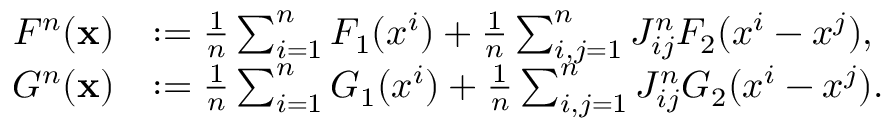Convert formula to latex. <formula><loc_0><loc_0><loc_500><loc_500>\begin{array} { r l } { F ^ { n } ( x ) } & { \colon = \frac { 1 } { n } \sum _ { i = 1 } ^ { n } F _ { 1 } ( x ^ { i } ) + \frac { 1 } { n } \sum _ { i , j = 1 } ^ { n } J _ { i j } ^ { n } F _ { 2 } ( x ^ { i } - x ^ { j } ) , } \\ { G ^ { n } ( x ) } & { \colon = \frac { 1 } { n } \sum _ { i = 1 } ^ { n } G _ { 1 } ( x ^ { i } ) + \frac { 1 } { n } \sum _ { i , j = 1 } ^ { n } J _ { i j } ^ { n } G _ { 2 } ( x ^ { i } - x ^ { j } ) . } \end{array}</formula> 